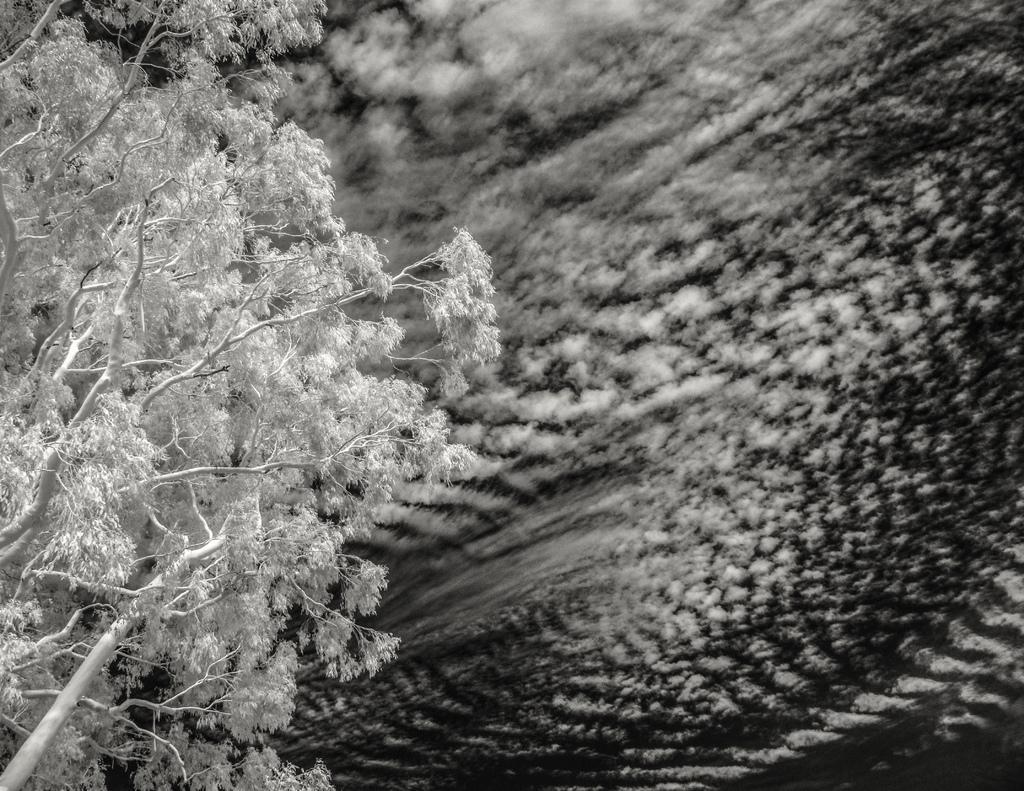How would you summarize this image in a sentence or two? This is a black and white image and here we can see a tree and the background is blurry. 